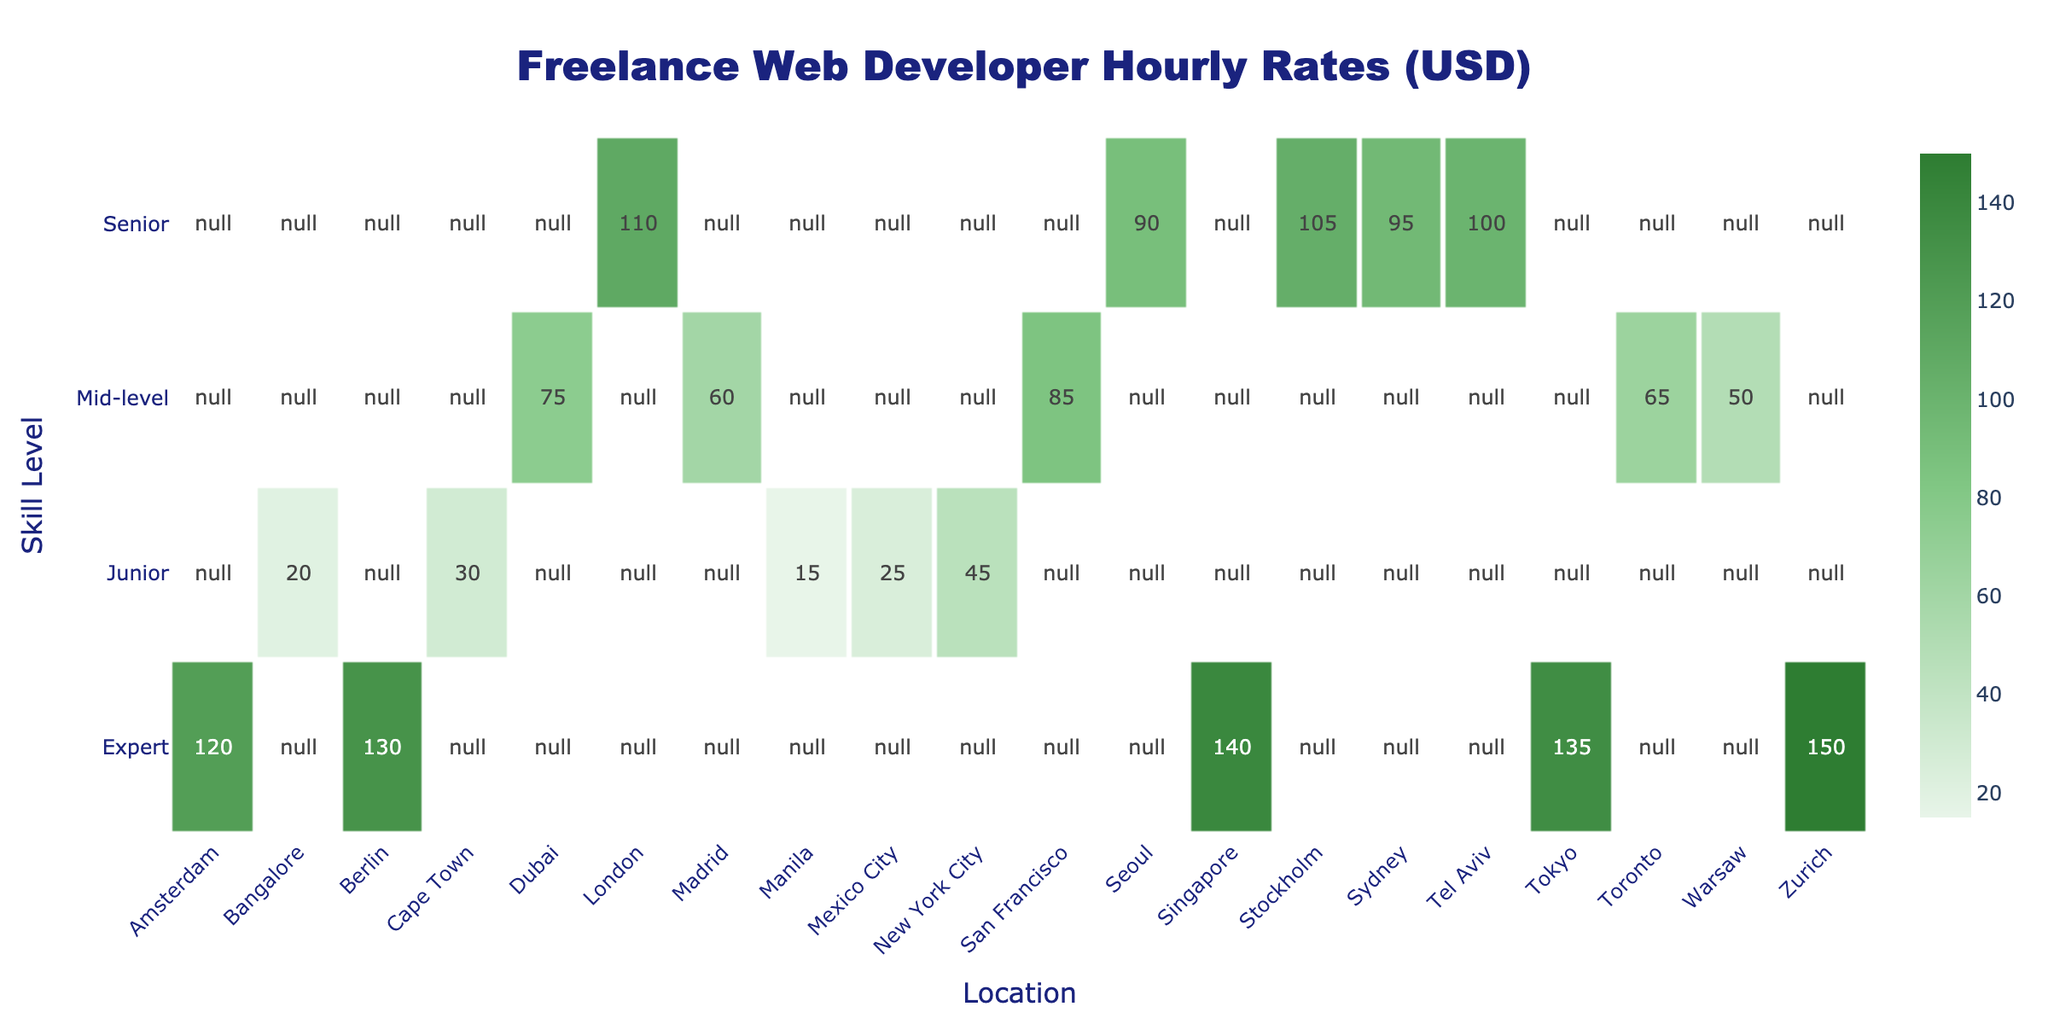What is the hourly rate for a Junior web developer in New York City? The table shows that the hourly rate for a Junior web developer in New York City is listed as 45 USD.
Answer: 45 Which location has the highest hourly rate for an Expert web developer? By checking the table, Singapore has the highest hourly rate for an Expert web developer at 140 USD.
Answer: 140 What is the difference between the hourly rates of Senior developers in London and Sydney? The hourly rate for a Senior developer in London is 110 USD, while in Sydney it is 95 USD. The difference is calculated as 110 - 95 = 15 USD.
Answer: 15 Is the hourly rate for a Mid-level developer in Toronto greater than that in Warsaw? The hourly rate for a Mid-level developer in Toronto is 65 USD, and in Warsaw it is 50 USD. Since 65 > 50, the statement is true.
Answer: Yes What is the median hourly rate for Junior developers across all locations? The hourly rates for Junior developers are: 45 (NYC), 20 (Bangalore), 15 (Manila), 25 (Mexico City), and 30 (Cape Town). Sorting these rates gives us: 15, 20, 25, 30, 45. The median is the middle value, which is 25 USD.
Answer: 25 What is the average hourly rate for Senior developers? The hourly rates for Senior developers are: 110 (London), 95 (Sydney), 100 (Tel Aviv), 105 (Stockholm), and 90 (Seoul). To find the average, we sum these values: 110 + 95 + 100 + 105 + 90 = 500, and divide by the number of developers (5), giving us 500 / 5 = 100 USD.
Answer: 100 How many locations offer an hourly rate of over 100 USD for Expert developers? The table lists Expert developers at the following rates: 130 (Berlin), 120 (Amsterdam), 140 (Singapore), and 150 (Zurich). All these rates are above 100 USD, so there are 4 locations in total.
Answer: 4 What is the total hourly rate for a Mid-level developer across all listed locations? The hourly rates for Mid-level developers are: 85 (San Francisco), 65 (Toronto), 75 (Dubai), 50 (Warsaw), and 60 (Madrid). The total is calculated as: 85 + 65 + 75 + 50 + 60 = 335 USD.
Answer: 335 Does an Expert developer in Tokyo earn more than a Senior developer in Seoul? The hourly rate for an Expert developer in Tokyo is 135 USD, while the rate for a Senior developer in Seoul is 90 USD. Since 135 > 90, the statement is true.
Answer: Yes Which skill level has the lowest hourly rate in the provided locations? Looking at the hourly rates for all skill levels, Junior developers have rates of 45 (NYC), 20 (Bangalore), 15 (Manila), 25 (Mexico City), and 30 (Cape Town), making the lowest rate 15 USD for Junior developers in Manila.
Answer: 15 